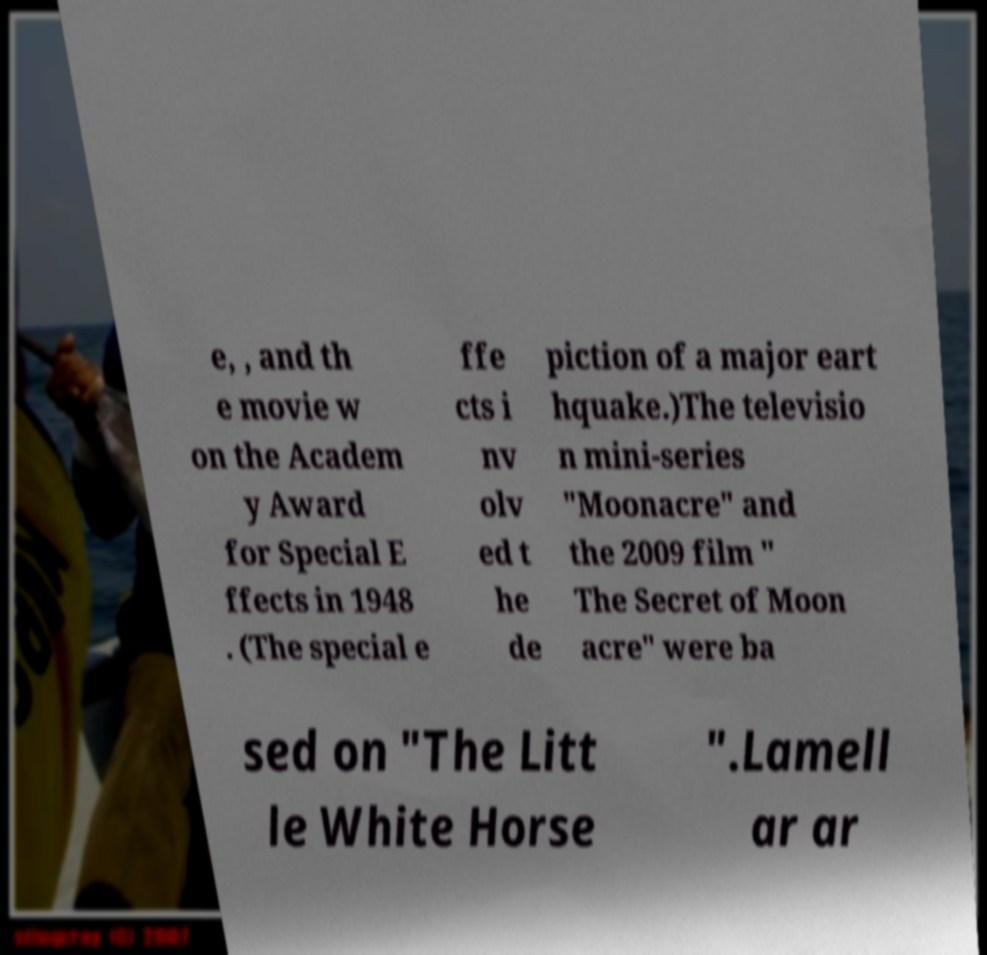There's text embedded in this image that I need extracted. Can you transcribe it verbatim? e, , and th e movie w on the Academ y Award for Special E ffects in 1948 . (The special e ffe cts i nv olv ed t he de piction of a major eart hquake.)The televisio n mini-series "Moonacre" and the 2009 film " The Secret of Moon acre" were ba sed on "The Litt le White Horse ".Lamell ar ar 